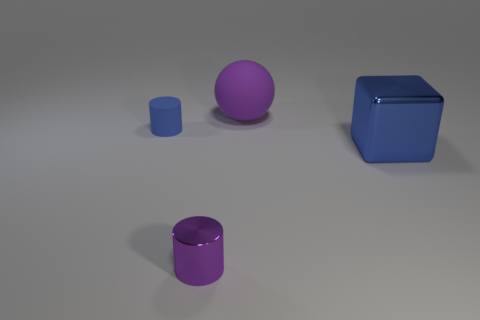Are there any blue rubber objects that have the same shape as the small metallic thing?
Ensure brevity in your answer.  Yes. Are the purple cylinder and the big thing right of the big sphere made of the same material?
Your answer should be compact. Yes. What material is the cylinder that is to the left of the small cylinder in front of the block made of?
Provide a short and direct response. Rubber. Is the number of big balls that are to the left of the big blue thing greater than the number of big gray things?
Offer a very short reply. Yes. Are any big cubes visible?
Provide a short and direct response. Yes. What color is the metal object that is right of the large purple thing?
Make the answer very short. Blue. There is another cylinder that is the same size as the rubber cylinder; what material is it?
Your answer should be compact. Metal. How many other things are the same material as the big ball?
Keep it short and to the point. 1. There is a thing that is both to the right of the purple cylinder and left of the big blue block; what color is it?
Your answer should be very brief. Purple. What number of objects are blue objects that are in front of the small blue thing or small metallic cylinders?
Your answer should be very brief. 2. 